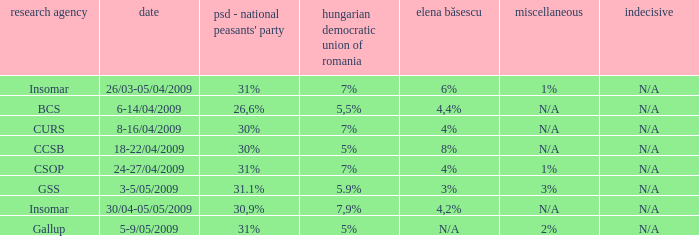What was the UDMR for 18-22/04/2009? 5%. 